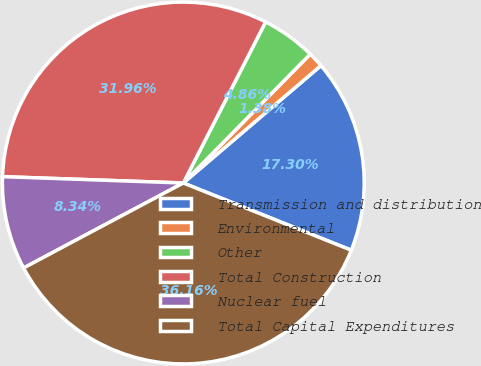Convert chart. <chart><loc_0><loc_0><loc_500><loc_500><pie_chart><fcel>Transmission and distribution<fcel>Environmental<fcel>Other<fcel>Total Construction<fcel>Nuclear fuel<fcel>Total Capital Expenditures<nl><fcel>17.3%<fcel>1.38%<fcel>4.86%<fcel>31.96%<fcel>8.34%<fcel>36.16%<nl></chart> 